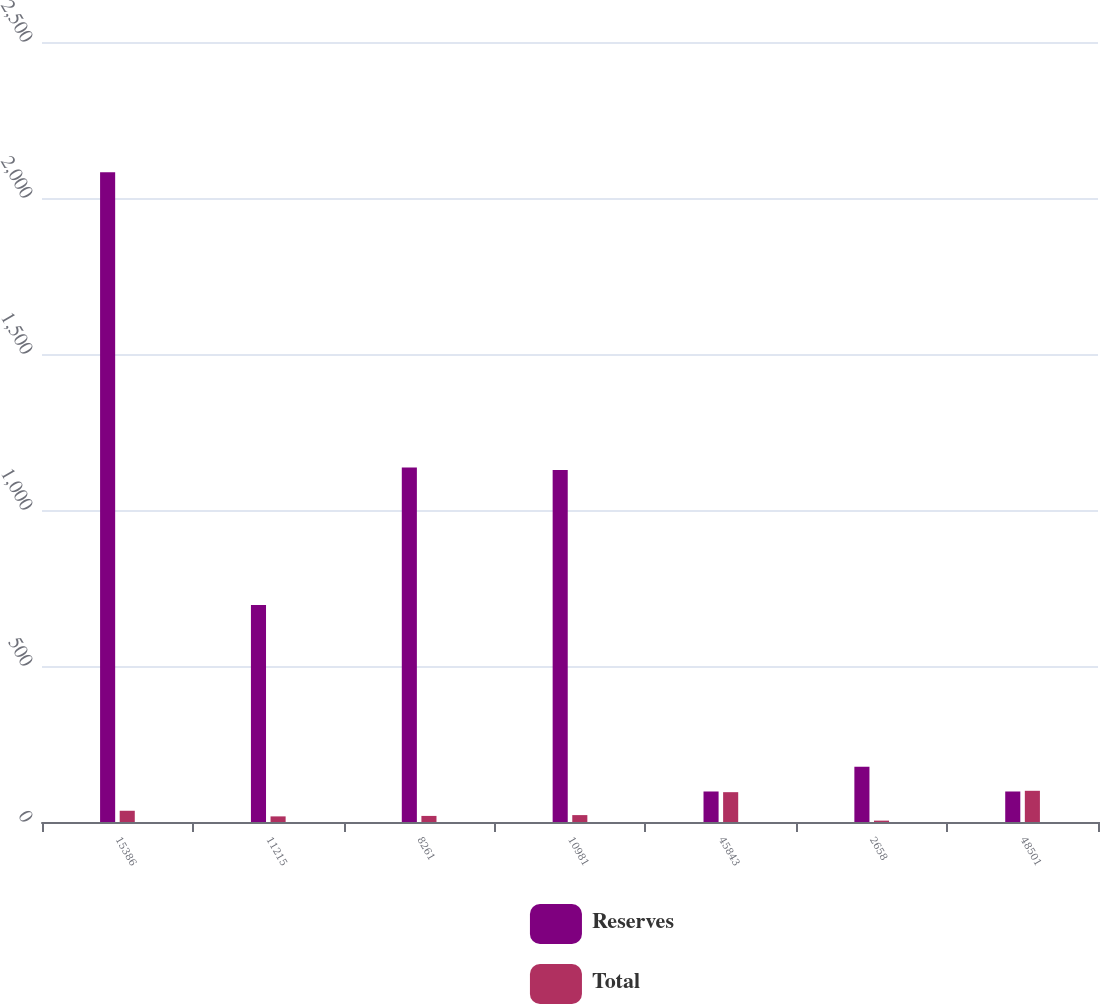Convert chart. <chart><loc_0><loc_0><loc_500><loc_500><stacked_bar_chart><ecel><fcel>15386<fcel>11215<fcel>8261<fcel>10981<fcel>45843<fcel>2658<fcel>48501<nl><fcel>Reserves<fcel>2082.6<fcel>695.3<fcel>1135.9<fcel>1128.1<fcel>97.8<fcel>177.1<fcel>97.8<nl><fcel>Total<fcel>36<fcel>18<fcel>19.5<fcel>22.1<fcel>95.6<fcel>4.4<fcel>100<nl></chart> 